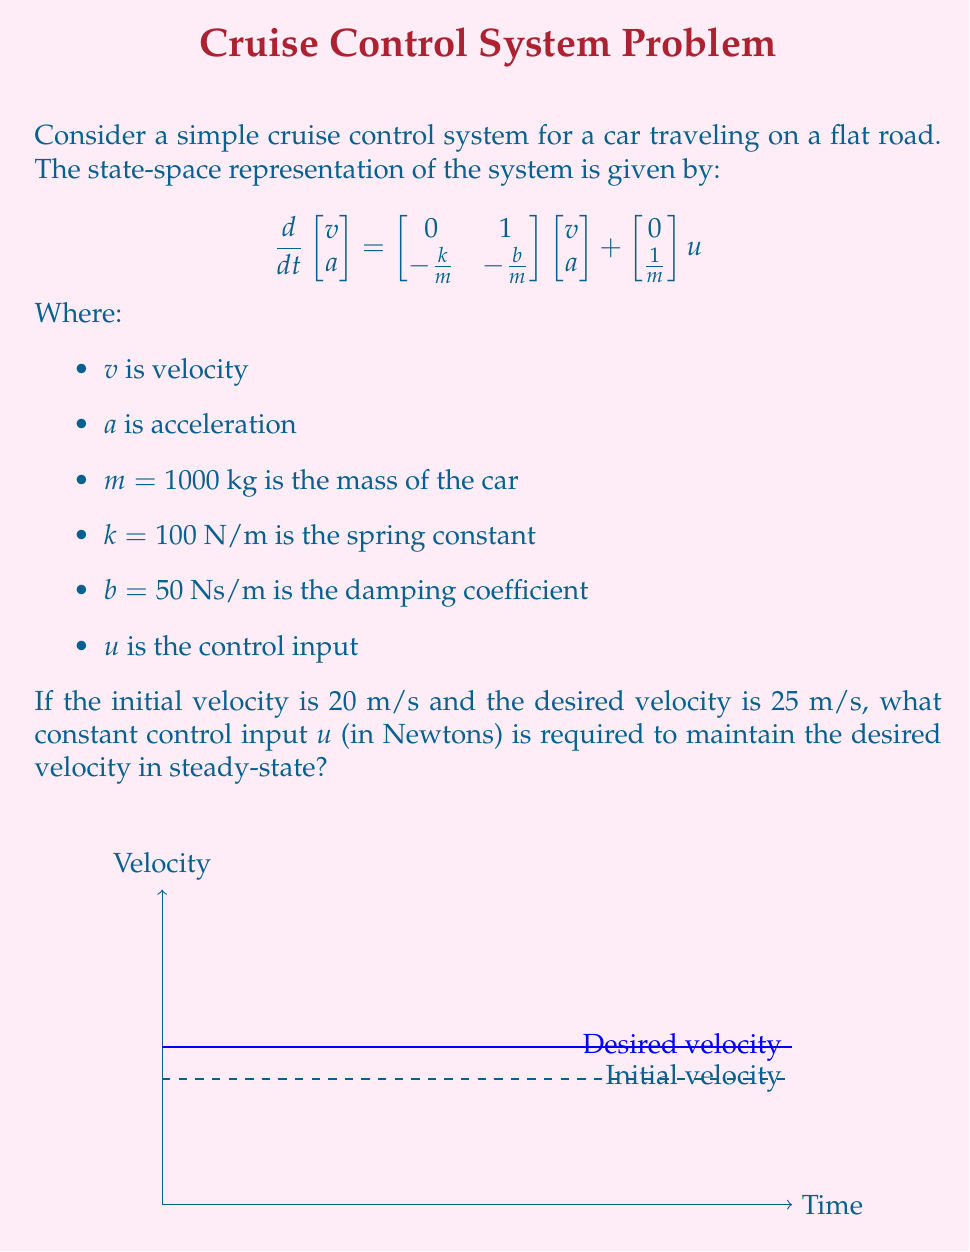Can you solve this math problem? To solve this problem, we need to follow these steps:

1) In steady-state, the derivative of the state vector is zero. So we can write:

   $$\begin{bmatrix} 0 \\ 0 \end{bmatrix} = \begin{bmatrix} 0 & 1 \\ -\frac{k}{m} & -\frac{b}{m} \end{bmatrix}\begin{bmatrix} v_{ss} \\ 0 \end{bmatrix} + \begin{bmatrix} 0 \\ \frac{1}{m} \end{bmatrix}u_{ss}$$

   Where $v_{ss}$ is the steady-state velocity and $u_{ss}$ is the steady-state control input.

2) From the first row of this equation:

   $$0 = 0 \cdot v_{ss} + 1 \cdot 0 + 0 \cdot u_{ss}$$

   This is always true, so it doesn't give us any useful information.

3) From the second row:

   $$0 = -\frac{k}{m}v_{ss} - \frac{b}{m} \cdot 0 + \frac{1}{m}u_{ss}$$

4) Simplify:

   $$0 = -\frac{k}{m}v_{ss} + \frac{1}{m}u_{ss}$$

5) Rearrange to solve for $u_{ss}$:

   $$u_{ss} = kv_{ss}$$

6) Substitute the known values:

   $$u_{ss} = 100 \cdot 25 = 2500 \text{ N}$$

Therefore, a constant control input of 2500 N is required to maintain the desired velocity of 25 m/s in steady-state.
Answer: 2500 N 